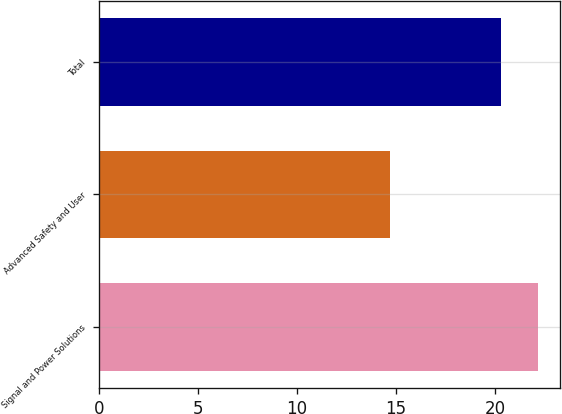Convert chart. <chart><loc_0><loc_0><loc_500><loc_500><bar_chart><fcel>Signal and Power Solutions<fcel>Advanced Safety and User<fcel>Total<nl><fcel>22.2<fcel>14.7<fcel>20.3<nl></chart> 